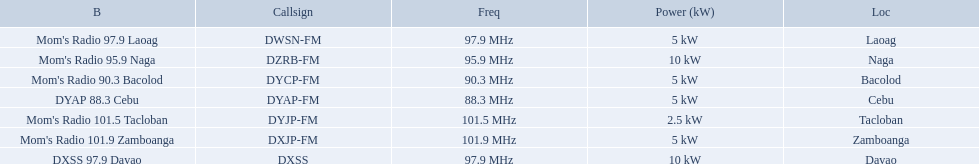What are all of the frequencies? 97.9 MHz, 95.9 MHz, 90.3 MHz, 88.3 MHz, 101.5 MHz, 101.9 MHz, 97.9 MHz. Which of these frequencies is the lowest? 88.3 MHz. Which branding does this frequency belong to? DYAP 88.3 Cebu. What brandings have a power of 5 kw? Mom's Radio 97.9 Laoag, Mom's Radio 90.3 Bacolod, DYAP 88.3 Cebu, Mom's Radio 101.9 Zamboanga. Which of these has a call-sign beginning with dy? Mom's Radio 90.3 Bacolod, DYAP 88.3 Cebu. Which of those uses the lowest frequency? DYAP 88.3 Cebu. 